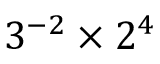Convert formula to latex. <formula><loc_0><loc_0><loc_500><loc_500>3 ^ { - 2 } \times 2 ^ { 4 }</formula> 